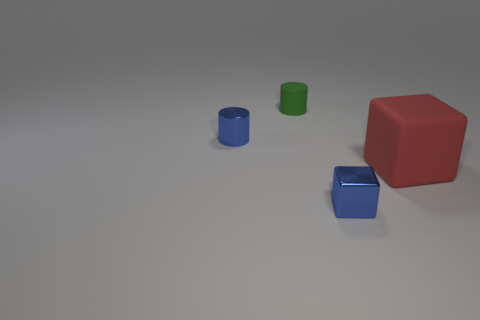What color is the metal thing that is the same shape as the small green matte thing?
Provide a short and direct response. Blue. Does the thing that is in front of the red object have the same material as the tiny cylinder in front of the matte cylinder?
Offer a very short reply. Yes. There is a tiny metal cylinder; is it the same color as the object that is in front of the matte block?
Your answer should be compact. Yes. There is a tiny object that is both on the right side of the blue cylinder and on the left side of the small blue block; what shape is it?
Offer a very short reply. Cylinder. How many matte cubes are there?
Make the answer very short. 1. There is a tiny thing that is the same color as the small metallic block; what is its shape?
Your answer should be very brief. Cylinder. There is another object that is the same shape as the red matte thing; what is its size?
Ensure brevity in your answer.  Small. There is a blue metallic object that is in front of the big red rubber cube; is its shape the same as the big rubber thing?
Provide a short and direct response. Yes. What is the color of the block to the left of the red rubber block?
Keep it short and to the point. Blue. How many other objects are the same size as the blue block?
Give a very brief answer. 2. 